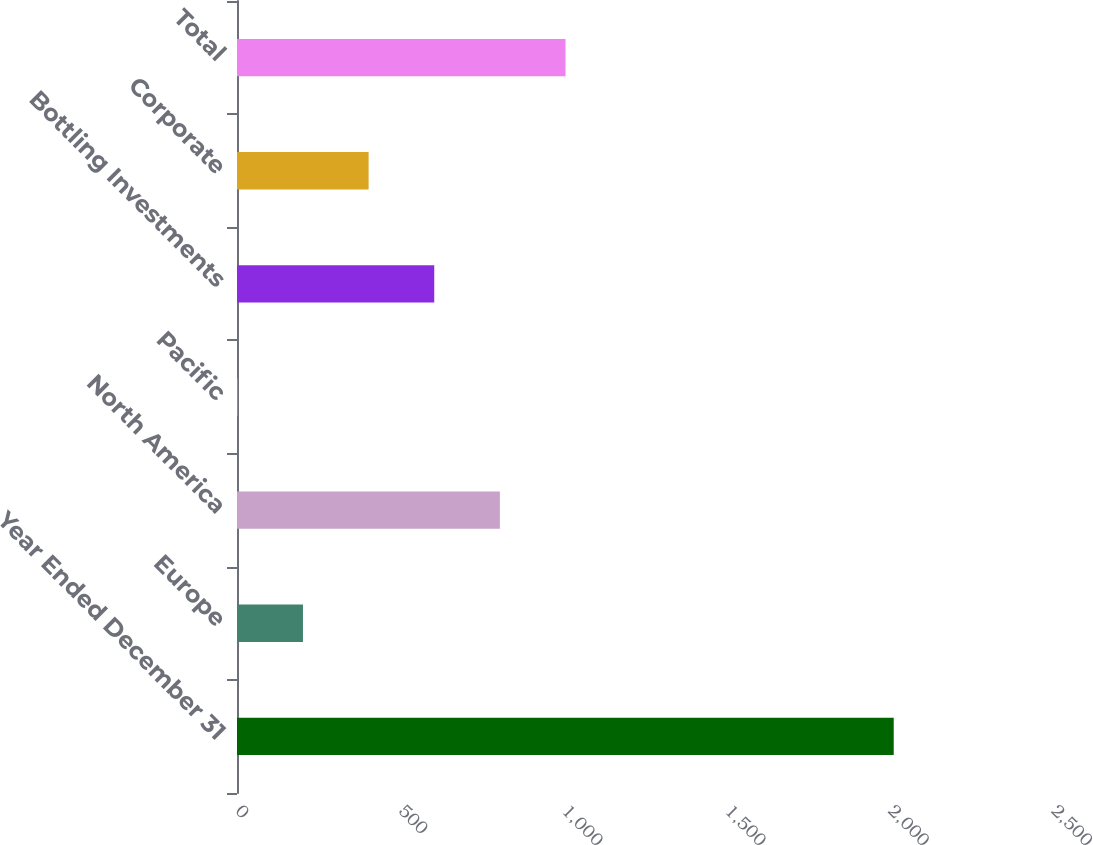<chart> <loc_0><loc_0><loc_500><loc_500><bar_chart><fcel>Year Ended December 31<fcel>Europe<fcel>North America<fcel>Pacific<fcel>Bottling Investments<fcel>Corporate<fcel>Total<nl><fcel>2012<fcel>202.1<fcel>805.4<fcel>1<fcel>604.3<fcel>403.2<fcel>1006.5<nl></chart> 